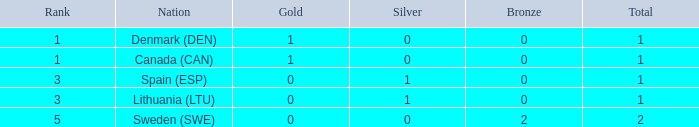What is the sum when there were fewer than 0 bronze? 0.0. 